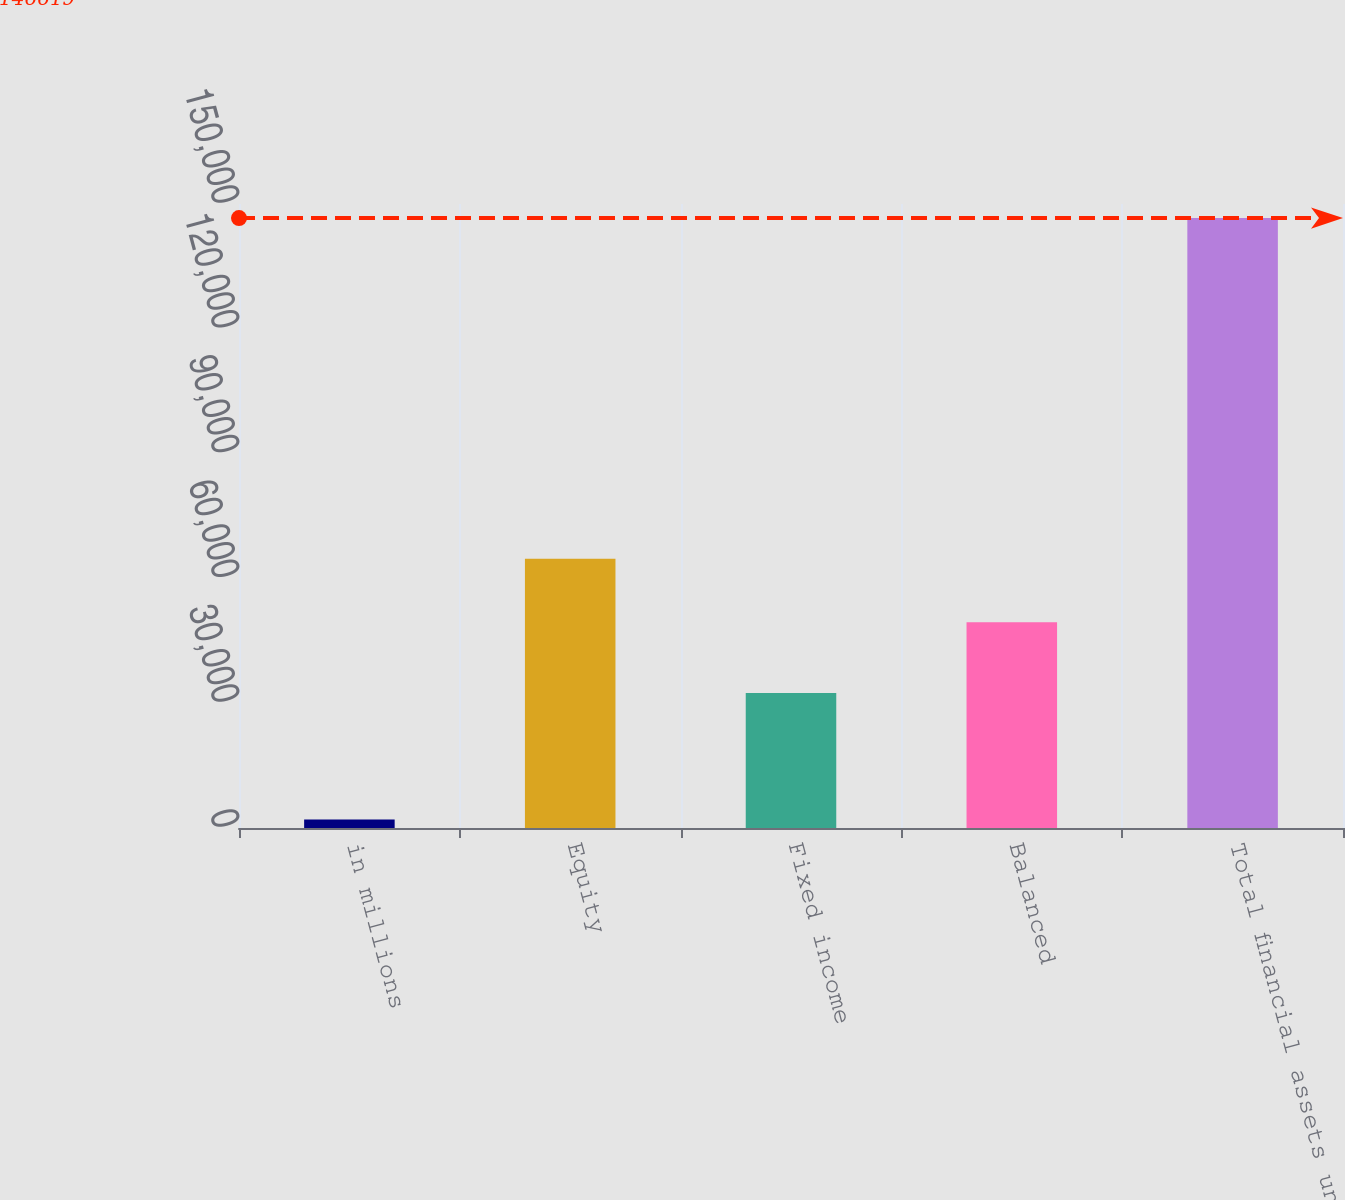Convert chart. <chart><loc_0><loc_0><loc_500><loc_500><bar_chart><fcel>in millions<fcel>Equity<fcel>Fixed income<fcel>Balanced<fcel>Total financial assets under<nl><fcel>2018<fcel>64742<fcel>32435<fcel>49442<fcel>146619<nl></chart> 